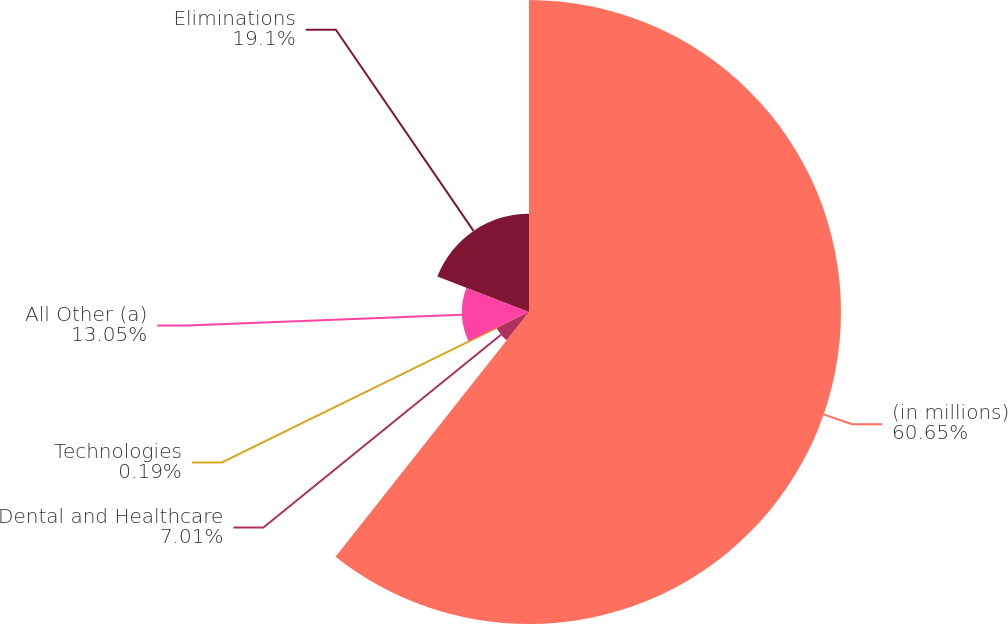Convert chart. <chart><loc_0><loc_0><loc_500><loc_500><pie_chart><fcel>(in millions)<fcel>Dental and Healthcare<fcel>Technologies<fcel>All Other (a)<fcel>Eliminations<nl><fcel>60.64%<fcel>7.01%<fcel>0.19%<fcel>13.05%<fcel>19.1%<nl></chart> 